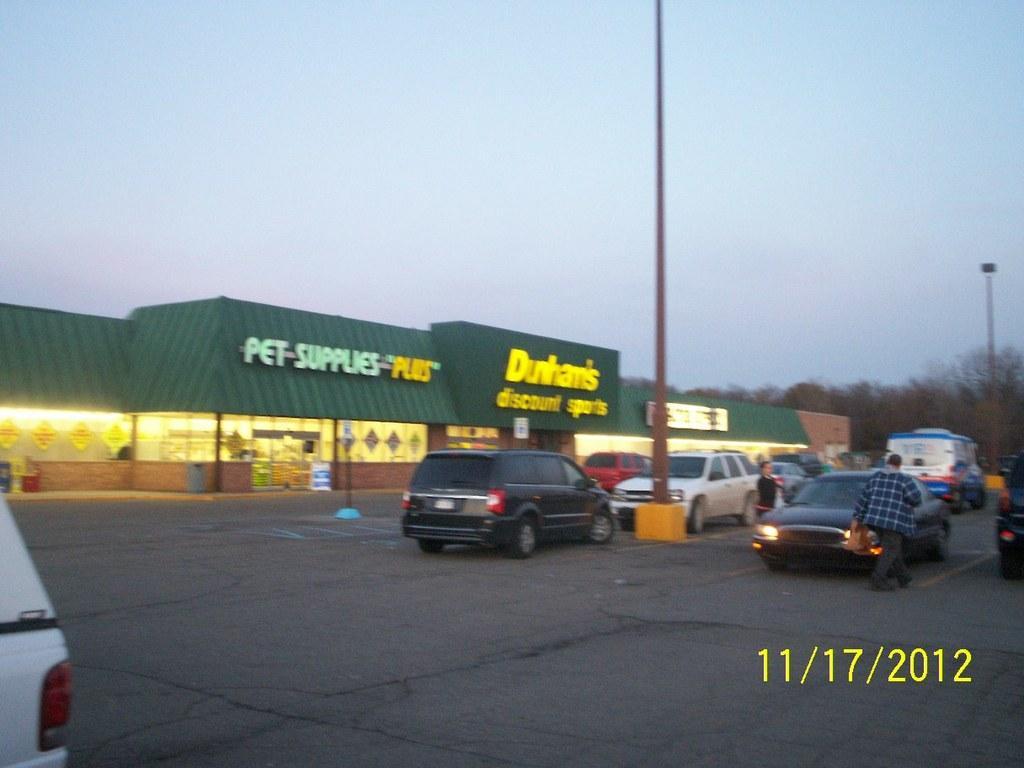Could you give a brief overview of what you see in this image? This is an outside view. In this image I can see many vehicles on the road and also there are two light poles. In the middle of the image there is a building. On the right side there are some trees. On the left side, I can see a part of a vehicle. At the top of the image I can see the sky. 